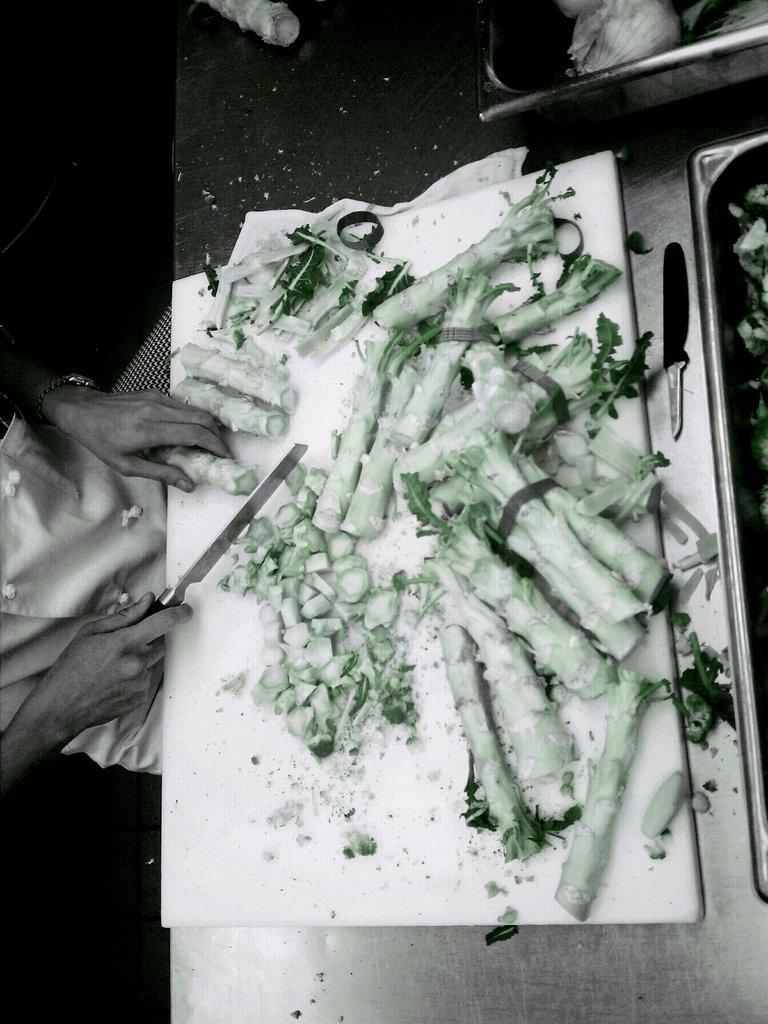Could you give a brief overview of what you see in this image? In this image we can see a person cutting vegetables on the cutting board. There is a table on which there are objects. 